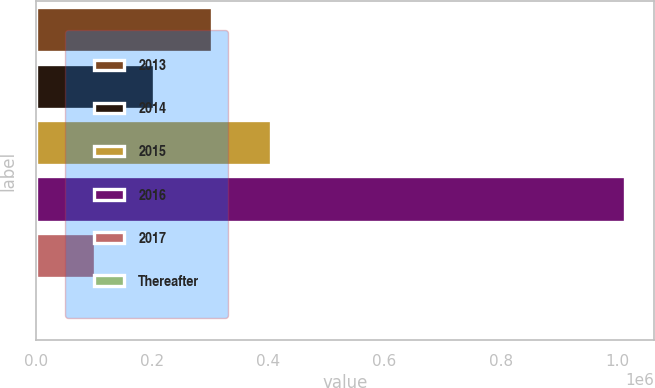Convert chart to OTSL. <chart><loc_0><loc_0><loc_500><loc_500><bar_chart><fcel>2013<fcel>2014<fcel>2015<fcel>2016<fcel>2017<fcel>Thereafter<nl><fcel>303886<fcel>202604<fcel>405169<fcel>1.01286e+06<fcel>101322<fcel>39<nl></chart> 